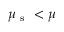Convert formula to latex. <formula><loc_0><loc_0><loc_500><loc_500>\mu _ { s } < \mu</formula> 